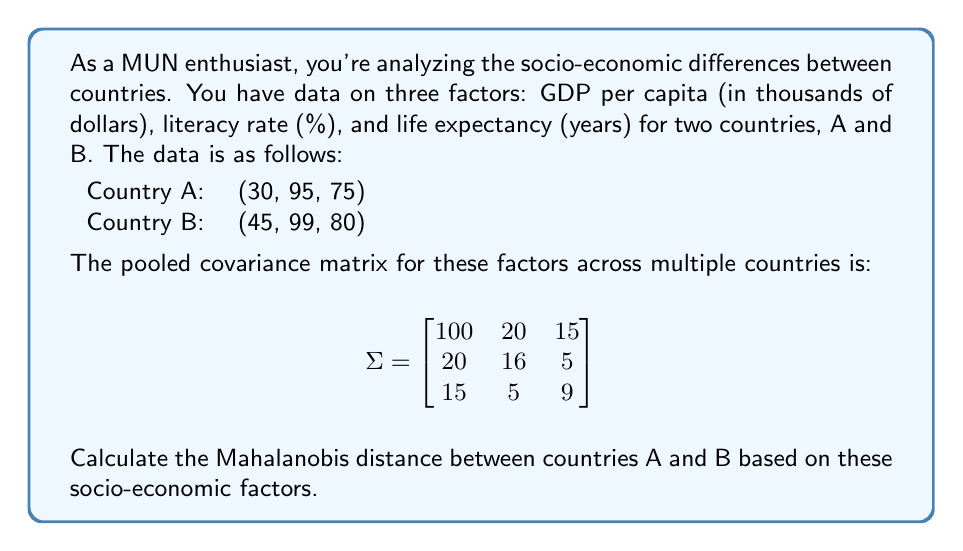Show me your answer to this math problem. To calculate the Mahalanobis distance between countries A and B, we'll follow these steps:

1) First, we need to find the difference vector between the two countries:
   $\mathbf{x}_A = (30, 95, 75)$
   $\mathbf{x}_B = (45, 99, 80)$
   $\mathbf{d} = \mathbf{x}_B - \mathbf{x}_A = (15, 4, 5)$

2) The Mahalanobis distance is given by the formula:
   $$D_M = \sqrt{(\mathbf{x}_B - \mathbf{x}_A)^T \Sigma^{-1} (\mathbf{x}_B - \mathbf{x}_A)}$$

3) We need to calculate $\Sigma^{-1}$. Using a calculator or computer, we get:
   $$\Sigma^{-1} = \begin{bmatrix}
   0.0107 & -0.0129 & -0.0162 \\
   -0.0129 & 0.0713 & -0.0271 \\
   -0.0162 & -0.0271 & 0.1284
   \end{bmatrix}$$

4) Now we can calculate the Mahalanobis distance:
   $$D_M = \sqrt{(15, 4, 5) \begin{bmatrix}
   0.0107 & -0.0129 & -0.0162 \\
   -0.0129 & 0.0713 & -0.0271 \\
   -0.0162 & -0.0271 & 0.1284
   \end{bmatrix} \begin{pmatrix} 15 \\ 4 \\ 5 \end{pmatrix}}$$

5) Multiplying the matrices:
   $$D_M = \sqrt{(15, 4, 5) \begin{pmatrix} -0.0935 \\ 0.0001 \\ 0.4702 \end{pmatrix}}$$

6) Completing the multiplication:
   $$D_M = \sqrt{-1.4025 + 0.0004 + 2.351} = \sqrt{0.9489}$$

7) Taking the square root:
   $$D_M = 0.9741$$
Answer: The Mahalanobis distance between countries A and B is approximately 0.9741. 